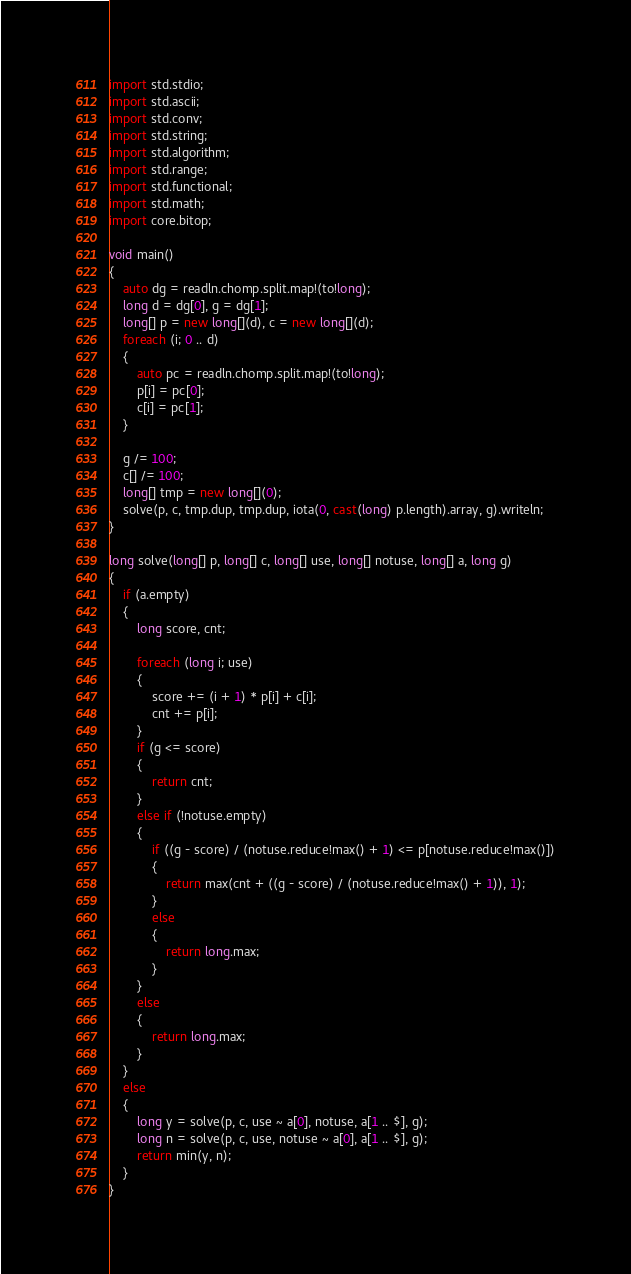Convert code to text. <code><loc_0><loc_0><loc_500><loc_500><_D_>import std.stdio;
import std.ascii;
import std.conv;
import std.string;
import std.algorithm;
import std.range;
import std.functional;
import std.math;
import core.bitop;

void main()
{
    auto dg = readln.chomp.split.map!(to!long);
    long d = dg[0], g = dg[1];
    long[] p = new long[](d), c = new long[](d);
    foreach (i; 0 .. d)
    {
        auto pc = readln.chomp.split.map!(to!long);
        p[i] = pc[0];
        c[i] = pc[1];
    }

    g /= 100;
    c[] /= 100;
    long[] tmp = new long[](0);
    solve(p, c, tmp.dup, tmp.dup, iota(0, cast(long) p.length).array, g).writeln;
}

long solve(long[] p, long[] c, long[] use, long[] notuse, long[] a, long g)
{
    if (a.empty)
    {
        long score, cnt;

        foreach (long i; use)
        {
            score += (i + 1) * p[i] + c[i];
            cnt += p[i];
        }
        if (g <= score)
        {
            return cnt;
        }
        else if (!notuse.empty)
        {
            if ((g - score) / (notuse.reduce!max() + 1) <= p[notuse.reduce!max()])
            {
                return max(cnt + ((g - score) / (notuse.reduce!max() + 1)), 1);
            }
            else
            {
                return long.max;
            }
        }
        else
        {
            return long.max;
        }
    }
    else
    {
        long y = solve(p, c, use ~ a[0], notuse, a[1 .. $], g);
        long n = solve(p, c, use, notuse ~ a[0], a[1 .. $], g);
        return min(y, n);
    }
}
</code> 